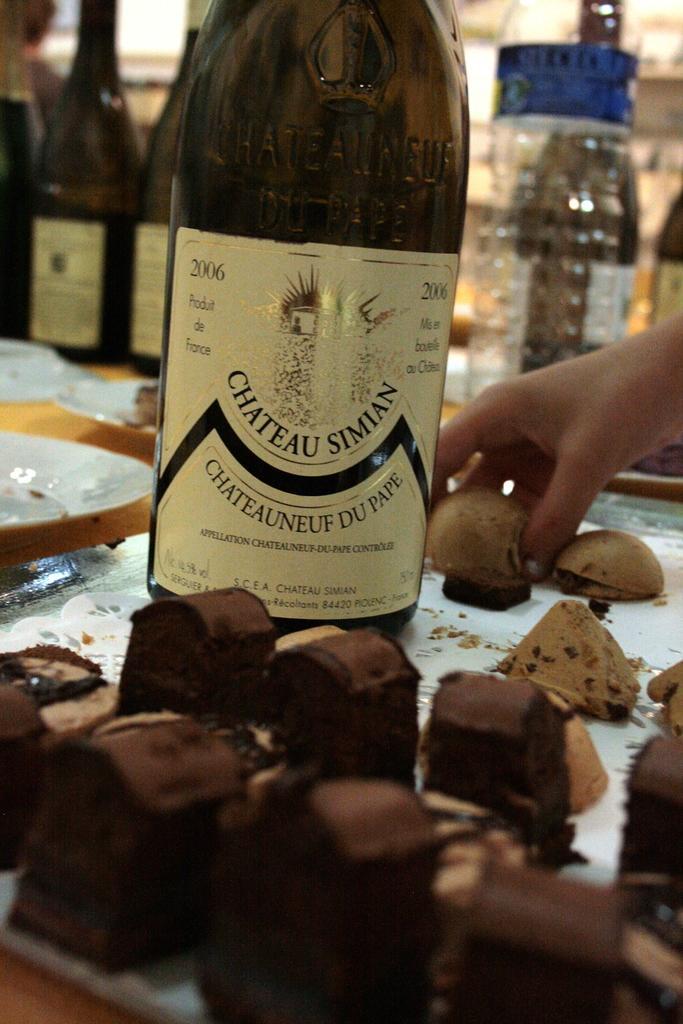Describe this image in one or two sentences. In this image i can see a glass bottle on a tray and few cookies and a person's hand holding the cookie. In the background i can see few glass bottles and few boxes. 